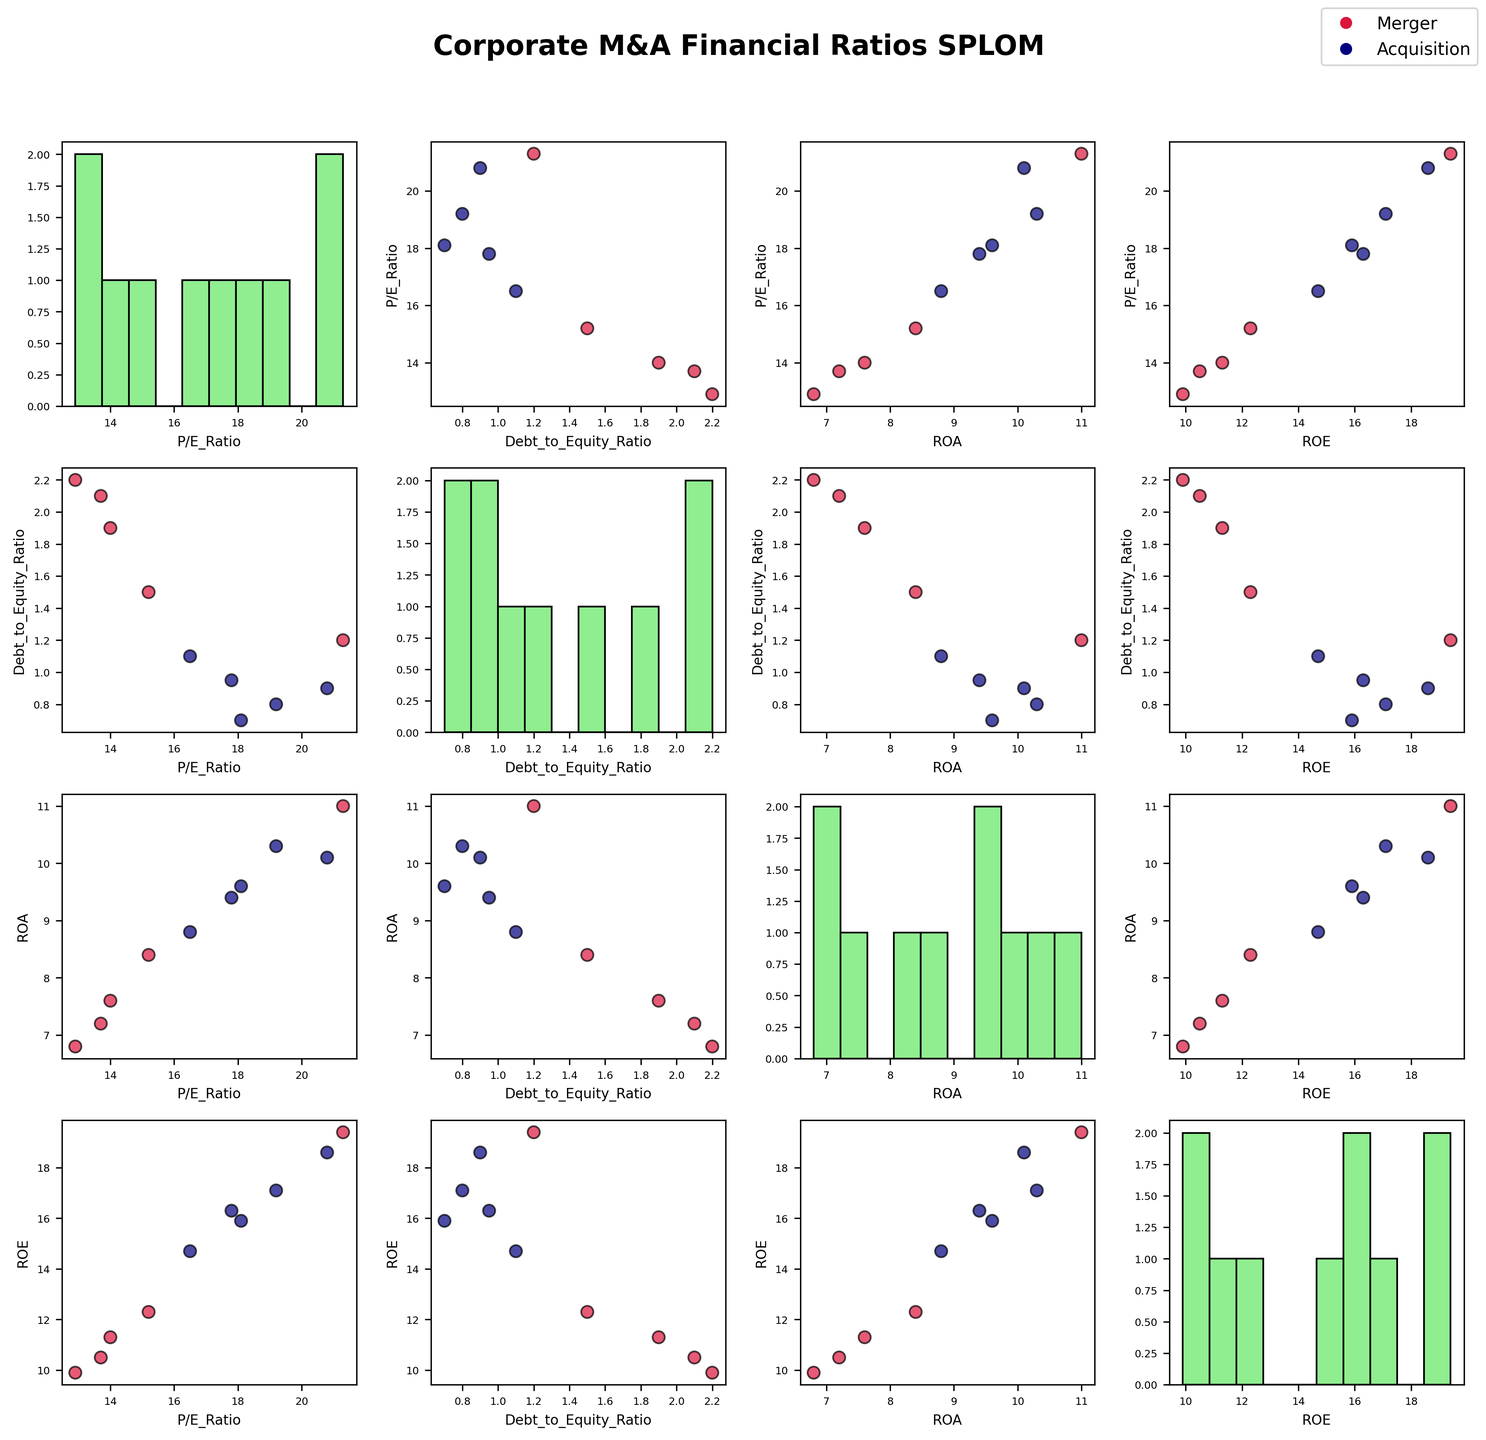What is the title of the plot? The title is displayed at the top of the figure, indicating the purpose of the visualization. It reads 'Corporate M&A Financial Ratios SPLOM' in bold, large font to stand out.
Answer: Corporate M&A Financial Ratios SPLOM What two colors are used to represent the different deal types in the scatter plots? The plot uses colors to distinguish between 'Merger' and 'Acquisition'. 'Merger' is represented by crimson, and 'Acquisition' is represented by navy, as seen in the scatter points and legend.
Answer: Crimson and Navy How many histogram plots can you find in the scatter plot matrix? The scatter plot matrix has histograms on the diagonal, representing the distribution of a single financial ratio for all companies. There are 4 numeric columns, so there are 4 histogram plots.
Answer: 4 Which financial ratio has the widest range of values shown in its histogram plot? By examining the width of the bins in the histogram plots, one can assess the spread of values. The P/E_Ratio plot has a wider range compared to others.
Answer: P/E_Ratio How does the Debt-to-Equity ratio compare between mergers and acquisitions in the scatter plot matrix? Looking at the scatter plots involving Debt-to-Equity ratios and noticing the color-coded points, acquisitions tend to have lower Debt-to-Equity ratios compared to mergers.
Answer: Acquisitions have lower Debt-to-Equity ratios What is the general trend between P/E Ratio and ROE in mergers? By observing the scatter plot of P/E Ratio vs. ROE, the red points (mergers) can be analyzed for patterns. The points show a positive correlation, indicating that higher P/E ratios are associated with higher ROEs.
Answer: Positive correlation Is there a significant visual difference in the ROA values between the two deal types? By comparing scatter plots involving ROA and noting the color-coded points, acquisitions (navy) generally have higher ROA values compared to mergers (crimson).
Answer: Acquisitions generally have higher ROA Which financial ratio appears to most consistently differentiate mergers from acquisitions? Looking at the scatter plots where one deal type significantly differs visually from the other, the Debt-to-Equity Ratio shows the most differentiation, with acquisitions having consistently lower values compared to mergers.
Answer: Debt-to-Equity Ratio What can you infer about the relationship between ROA and ROE from the scatter plot matrix? Checking the ROA vs. ROE scatter plot for patterns among points, there is a strong positive correlation indicating that companies with higher ROA tend to also have higher ROE irrespective of the deal type.
Answer: Positive correlation Which combination of financial ratios shows the least correlation in the scatter plot matrix? By examining the scatter plots and assessing the position and spread of the points, the P/E Ratio vs. Debt-to-Equity Ratio seems to have the least correlation as the points are widely scattered without a clear pattern.
Answer: P/E Ratio vs. Debt-to-Equity Ratio 